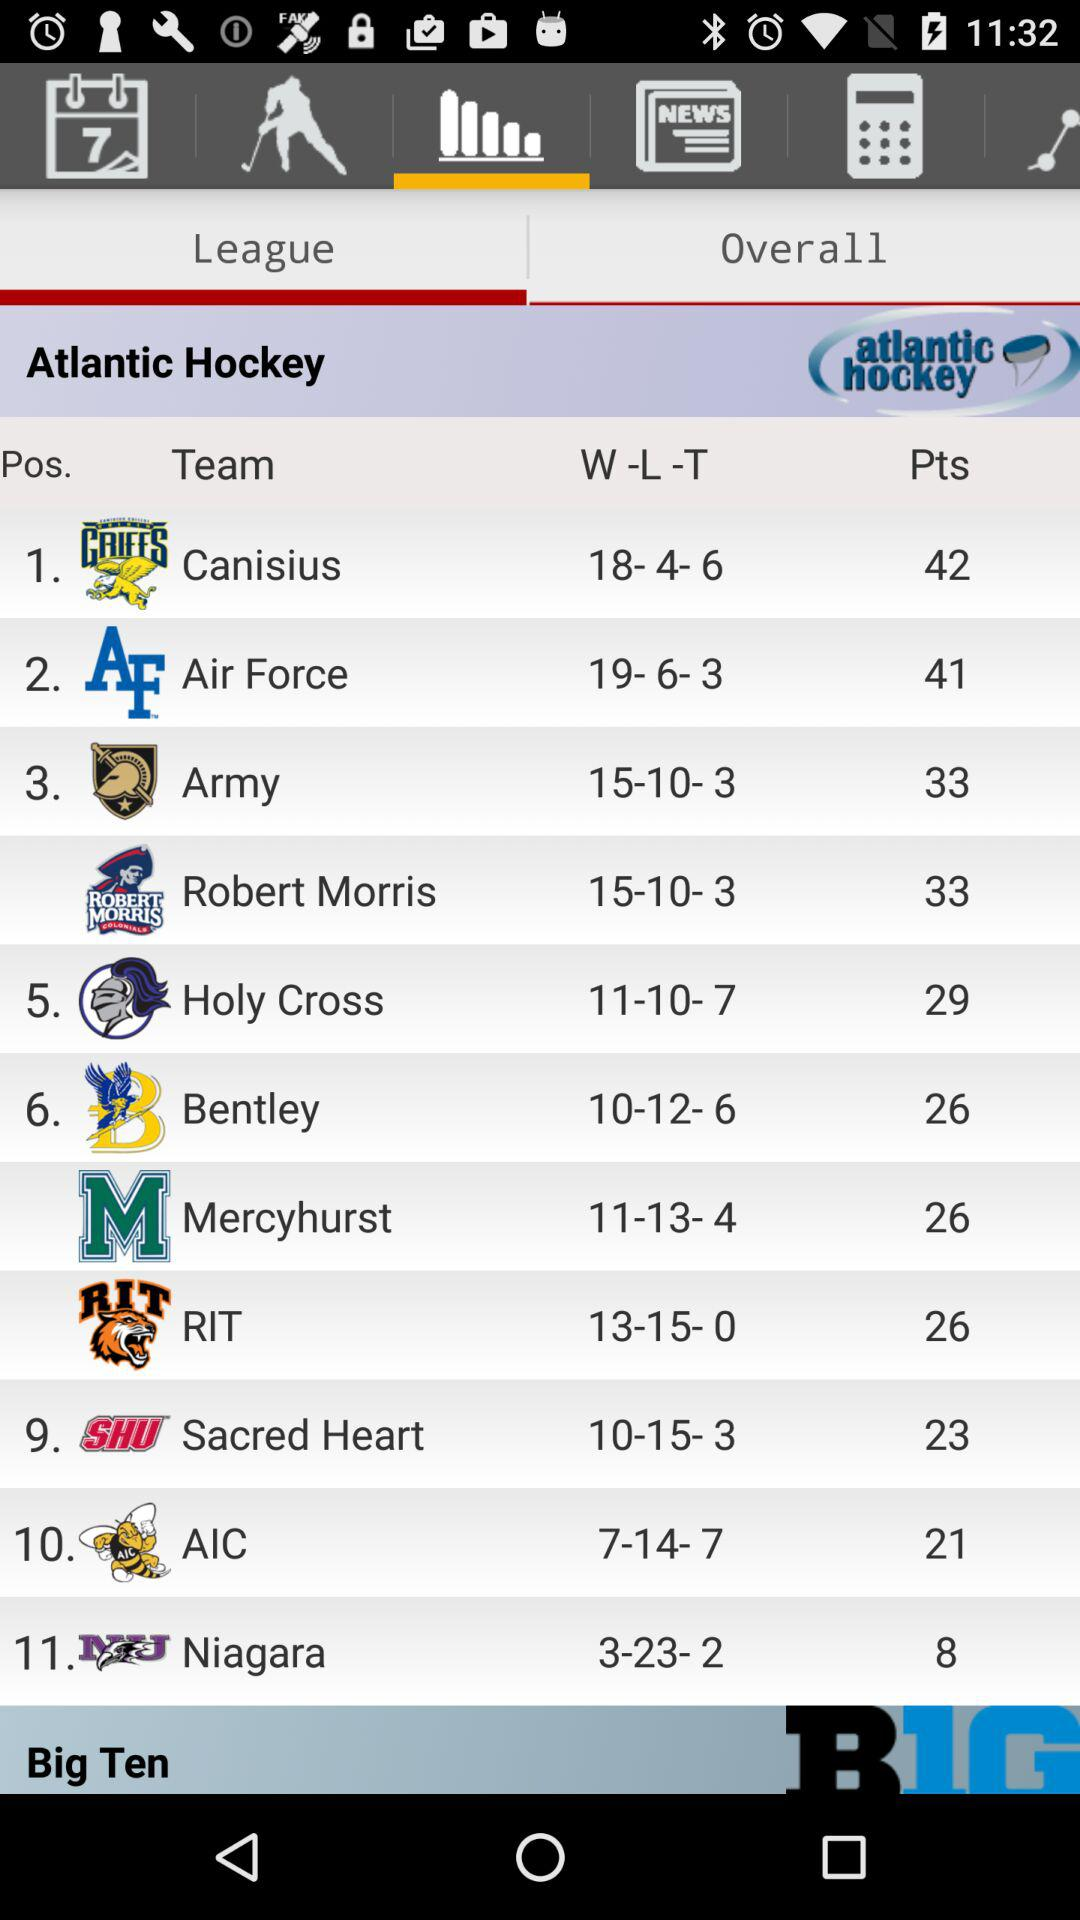What are the different teams in the "Atlantic Hockey League"? The teams in the "Atlantic Hockey League" are "Canisius", "Air Force", "Army", "Robert Morris", "Holy Cross", "Bentley", "Mercyhurst", "RIT", "Sacred Heart", "AIC" and "Niagara". 